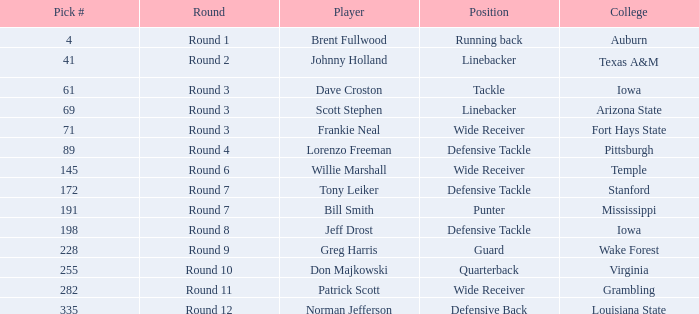In the 7th round, which college was tony leiker a part of? Stanford. 